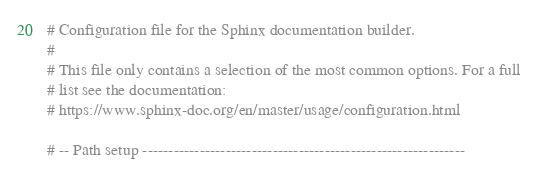Convert code to text. <code><loc_0><loc_0><loc_500><loc_500><_Python_># Configuration file for the Sphinx documentation builder.
#
# This file only contains a selection of the most common options. For a full
# list see the documentation:
# https://www.sphinx-doc.org/en/master/usage/configuration.html

# -- Path setup --------------------------------------------------------------
</code> 